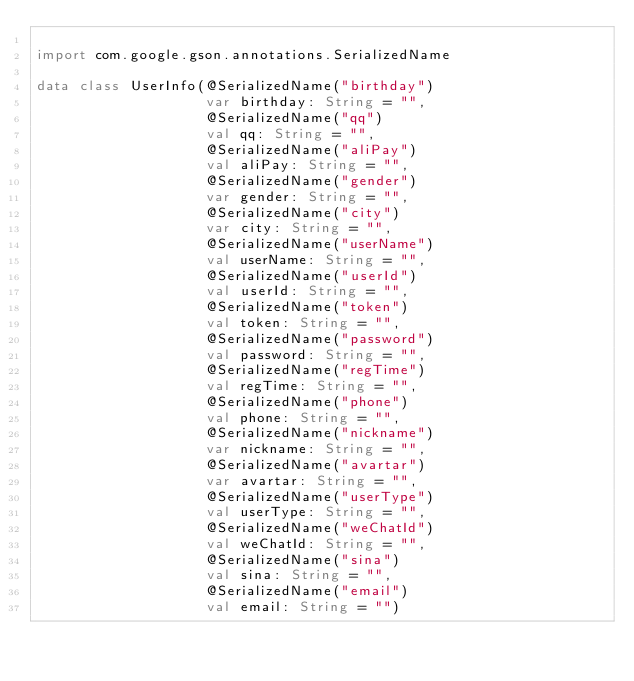<code> <loc_0><loc_0><loc_500><loc_500><_Kotlin_>
import com.google.gson.annotations.SerializedName

data class UserInfo(@SerializedName("birthday")
                    var birthday: String = "",
                    @SerializedName("qq")
                    val qq: String = "",
                    @SerializedName("aliPay")
                    val aliPay: String = "",
                    @SerializedName("gender")
                    var gender: String = "",
                    @SerializedName("city")
                    var city: String = "",
                    @SerializedName("userName")
                    val userName: String = "",
                    @SerializedName("userId")
                    val userId: String = "",
                    @SerializedName("token")
                    val token: String = "",
                    @SerializedName("password")
                    val password: String = "",
                    @SerializedName("regTime")
                    val regTime: String = "",
                    @SerializedName("phone")
                    val phone: String = "",
                    @SerializedName("nickname")
                    var nickname: String = "",
                    @SerializedName("avartar")
                    var avartar: String = "",
                    @SerializedName("userType")
                    val userType: String = "",
                    @SerializedName("weChatId")
                    val weChatId: String = "",
                    @SerializedName("sina")
                    val sina: String = "",
                    @SerializedName("email")
                    val email: String = "")</code> 